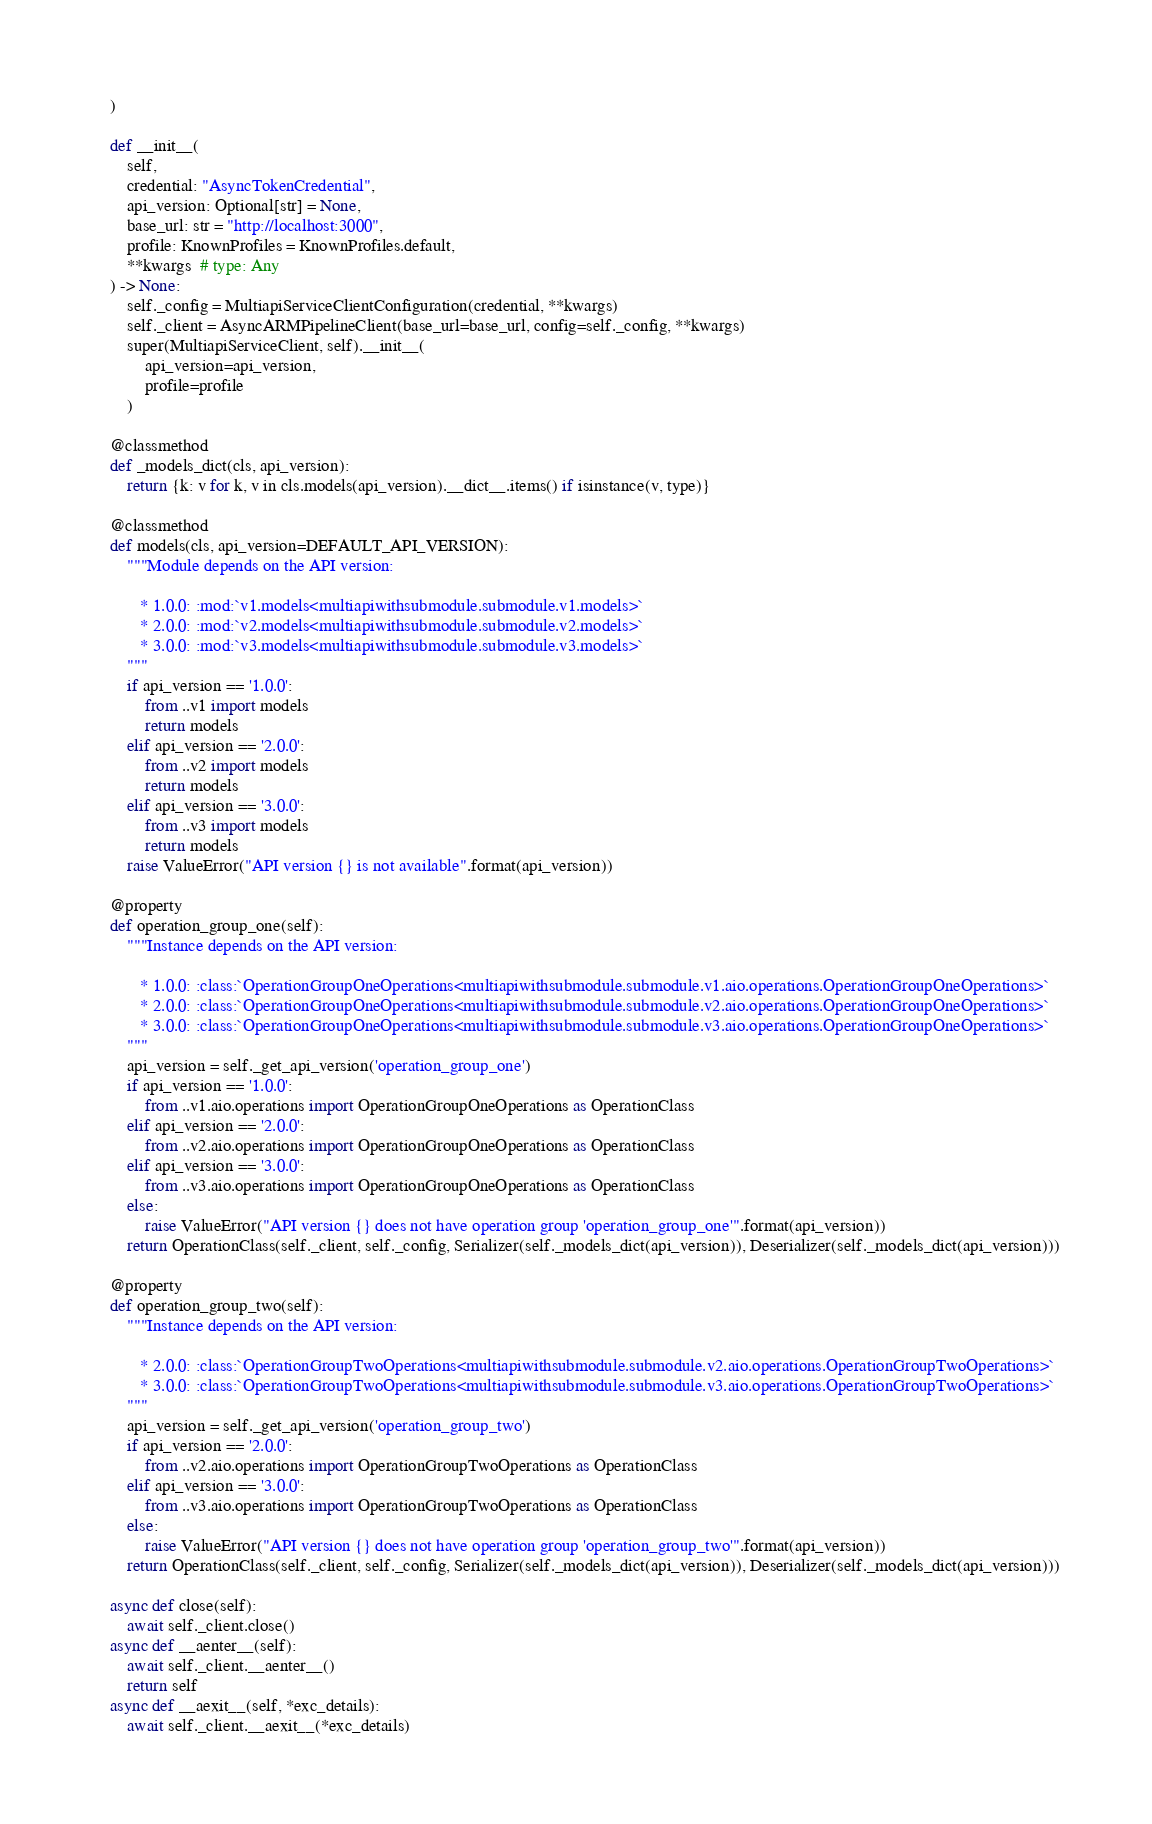<code> <loc_0><loc_0><loc_500><loc_500><_Python_>    )

    def __init__(
        self,
        credential: "AsyncTokenCredential",
        api_version: Optional[str] = None,
        base_url: str = "http://localhost:3000",
        profile: KnownProfiles = KnownProfiles.default,
        **kwargs  # type: Any
    ) -> None:
        self._config = MultiapiServiceClientConfiguration(credential, **kwargs)
        self._client = AsyncARMPipelineClient(base_url=base_url, config=self._config, **kwargs)
        super(MultiapiServiceClient, self).__init__(
            api_version=api_version,
            profile=profile
        )

    @classmethod
    def _models_dict(cls, api_version):
        return {k: v for k, v in cls.models(api_version).__dict__.items() if isinstance(v, type)}

    @classmethod
    def models(cls, api_version=DEFAULT_API_VERSION):
        """Module depends on the API version:

           * 1.0.0: :mod:`v1.models<multiapiwithsubmodule.submodule.v1.models>`
           * 2.0.0: :mod:`v2.models<multiapiwithsubmodule.submodule.v2.models>`
           * 3.0.0: :mod:`v3.models<multiapiwithsubmodule.submodule.v3.models>`
        """
        if api_version == '1.0.0':
            from ..v1 import models
            return models
        elif api_version == '2.0.0':
            from ..v2 import models
            return models
        elif api_version == '3.0.0':
            from ..v3 import models
            return models
        raise ValueError("API version {} is not available".format(api_version))

    @property
    def operation_group_one(self):
        """Instance depends on the API version:

           * 1.0.0: :class:`OperationGroupOneOperations<multiapiwithsubmodule.submodule.v1.aio.operations.OperationGroupOneOperations>`
           * 2.0.0: :class:`OperationGroupOneOperations<multiapiwithsubmodule.submodule.v2.aio.operations.OperationGroupOneOperations>`
           * 3.0.0: :class:`OperationGroupOneOperations<multiapiwithsubmodule.submodule.v3.aio.operations.OperationGroupOneOperations>`
        """
        api_version = self._get_api_version('operation_group_one')
        if api_version == '1.0.0':
            from ..v1.aio.operations import OperationGroupOneOperations as OperationClass
        elif api_version == '2.0.0':
            from ..v2.aio.operations import OperationGroupOneOperations as OperationClass
        elif api_version == '3.0.0':
            from ..v3.aio.operations import OperationGroupOneOperations as OperationClass
        else:
            raise ValueError("API version {} does not have operation group 'operation_group_one'".format(api_version))
        return OperationClass(self._client, self._config, Serializer(self._models_dict(api_version)), Deserializer(self._models_dict(api_version)))

    @property
    def operation_group_two(self):
        """Instance depends on the API version:

           * 2.0.0: :class:`OperationGroupTwoOperations<multiapiwithsubmodule.submodule.v2.aio.operations.OperationGroupTwoOperations>`
           * 3.0.0: :class:`OperationGroupTwoOperations<multiapiwithsubmodule.submodule.v3.aio.operations.OperationGroupTwoOperations>`
        """
        api_version = self._get_api_version('operation_group_two')
        if api_version == '2.0.0':
            from ..v2.aio.operations import OperationGroupTwoOperations as OperationClass
        elif api_version == '3.0.0':
            from ..v3.aio.operations import OperationGroupTwoOperations as OperationClass
        else:
            raise ValueError("API version {} does not have operation group 'operation_group_two'".format(api_version))
        return OperationClass(self._client, self._config, Serializer(self._models_dict(api_version)), Deserializer(self._models_dict(api_version)))

    async def close(self):
        await self._client.close()
    async def __aenter__(self):
        await self._client.__aenter__()
        return self
    async def __aexit__(self, *exc_details):
        await self._client.__aexit__(*exc_details)
</code> 